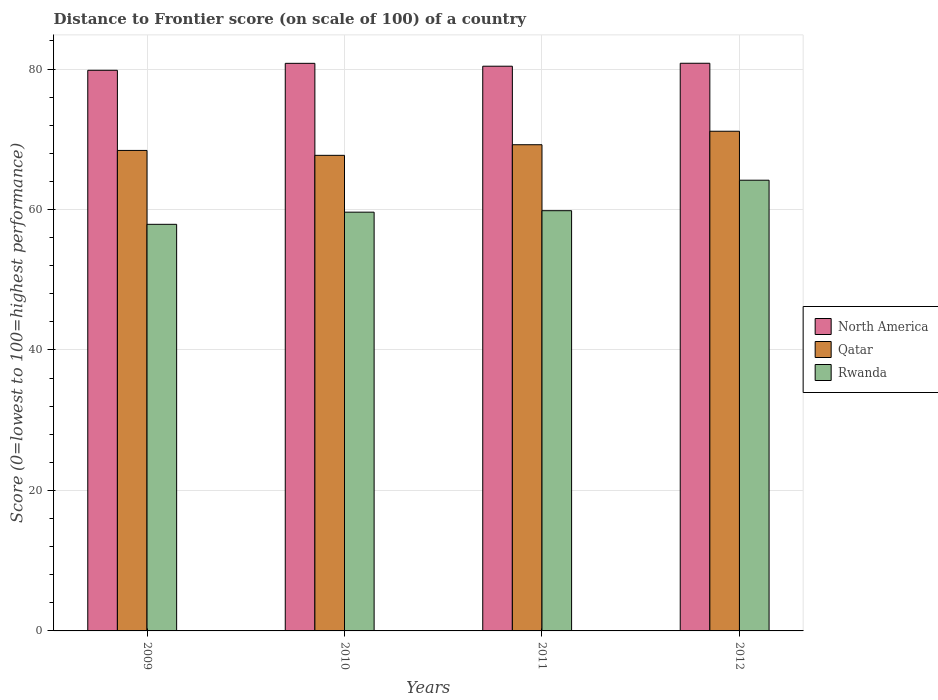How many different coloured bars are there?
Your answer should be very brief. 3. How many bars are there on the 4th tick from the left?
Provide a succinct answer. 3. How many bars are there on the 4th tick from the right?
Your answer should be compact. 3. What is the distance to frontier score of in Rwanda in 2012?
Make the answer very short. 64.17. Across all years, what is the maximum distance to frontier score of in Rwanda?
Offer a terse response. 64.17. Across all years, what is the minimum distance to frontier score of in Qatar?
Your response must be concise. 67.71. What is the total distance to frontier score of in North America in the graph?
Give a very brief answer. 321.85. What is the difference between the distance to frontier score of in Qatar in 2010 and that in 2011?
Your answer should be very brief. -1.51. What is the difference between the distance to frontier score of in Rwanda in 2011 and the distance to frontier score of in Qatar in 2009?
Your answer should be compact. -8.58. What is the average distance to frontier score of in Qatar per year?
Offer a terse response. 69.12. In the year 2009, what is the difference between the distance to frontier score of in Rwanda and distance to frontier score of in North America?
Ensure brevity in your answer.  -21.93. What is the ratio of the distance to frontier score of in North America in 2011 to that in 2012?
Provide a short and direct response. 0.99. Is the difference between the distance to frontier score of in Rwanda in 2010 and 2012 greater than the difference between the distance to frontier score of in North America in 2010 and 2012?
Your answer should be compact. No. What is the difference between the highest and the second highest distance to frontier score of in North America?
Make the answer very short. 0.01. What is the difference between the highest and the lowest distance to frontier score of in Qatar?
Your response must be concise. 3.43. In how many years, is the distance to frontier score of in Rwanda greater than the average distance to frontier score of in Rwanda taken over all years?
Your answer should be very brief. 1. What does the 3rd bar from the left in 2009 represents?
Give a very brief answer. Rwanda. What does the 3rd bar from the right in 2012 represents?
Your answer should be compact. North America. Is it the case that in every year, the sum of the distance to frontier score of in North America and distance to frontier score of in Qatar is greater than the distance to frontier score of in Rwanda?
Provide a short and direct response. Yes. How many bars are there?
Offer a very short reply. 12. How many years are there in the graph?
Your answer should be compact. 4. What is the difference between two consecutive major ticks on the Y-axis?
Give a very brief answer. 20. Does the graph contain any zero values?
Give a very brief answer. No. Does the graph contain grids?
Your answer should be very brief. Yes. How are the legend labels stacked?
Offer a terse response. Vertical. What is the title of the graph?
Your answer should be compact. Distance to Frontier score (on scale of 100) of a country. What is the label or title of the X-axis?
Give a very brief answer. Years. What is the label or title of the Y-axis?
Offer a terse response. Score (0=lowest to 100=highest performance). What is the Score (0=lowest to 100=highest performance) in North America in 2009?
Provide a succinct answer. 79.82. What is the Score (0=lowest to 100=highest performance) of Qatar in 2009?
Provide a succinct answer. 68.41. What is the Score (0=lowest to 100=highest performance) in Rwanda in 2009?
Offer a terse response. 57.89. What is the Score (0=lowest to 100=highest performance) of North America in 2010?
Provide a succinct answer. 80.81. What is the Score (0=lowest to 100=highest performance) in Qatar in 2010?
Make the answer very short. 67.71. What is the Score (0=lowest to 100=highest performance) in Rwanda in 2010?
Your answer should be compact. 59.62. What is the Score (0=lowest to 100=highest performance) of North America in 2011?
Provide a short and direct response. 80.4. What is the Score (0=lowest to 100=highest performance) of Qatar in 2011?
Ensure brevity in your answer.  69.22. What is the Score (0=lowest to 100=highest performance) of Rwanda in 2011?
Offer a terse response. 59.83. What is the Score (0=lowest to 100=highest performance) in North America in 2012?
Offer a very short reply. 80.82. What is the Score (0=lowest to 100=highest performance) in Qatar in 2012?
Your response must be concise. 71.14. What is the Score (0=lowest to 100=highest performance) in Rwanda in 2012?
Make the answer very short. 64.17. Across all years, what is the maximum Score (0=lowest to 100=highest performance) of North America?
Ensure brevity in your answer.  80.82. Across all years, what is the maximum Score (0=lowest to 100=highest performance) in Qatar?
Your answer should be very brief. 71.14. Across all years, what is the maximum Score (0=lowest to 100=highest performance) of Rwanda?
Make the answer very short. 64.17. Across all years, what is the minimum Score (0=lowest to 100=highest performance) in North America?
Make the answer very short. 79.82. Across all years, what is the minimum Score (0=lowest to 100=highest performance) in Qatar?
Your response must be concise. 67.71. Across all years, what is the minimum Score (0=lowest to 100=highest performance) of Rwanda?
Provide a short and direct response. 57.89. What is the total Score (0=lowest to 100=highest performance) in North America in the graph?
Your answer should be compact. 321.85. What is the total Score (0=lowest to 100=highest performance) of Qatar in the graph?
Your answer should be very brief. 276.48. What is the total Score (0=lowest to 100=highest performance) in Rwanda in the graph?
Provide a short and direct response. 241.51. What is the difference between the Score (0=lowest to 100=highest performance) of North America in 2009 and that in 2010?
Provide a succinct answer. -0.99. What is the difference between the Score (0=lowest to 100=highest performance) in Rwanda in 2009 and that in 2010?
Keep it short and to the point. -1.73. What is the difference between the Score (0=lowest to 100=highest performance) in North America in 2009 and that in 2011?
Keep it short and to the point. -0.58. What is the difference between the Score (0=lowest to 100=highest performance) in Qatar in 2009 and that in 2011?
Offer a very short reply. -0.81. What is the difference between the Score (0=lowest to 100=highest performance) in Rwanda in 2009 and that in 2011?
Your response must be concise. -1.94. What is the difference between the Score (0=lowest to 100=highest performance) in Qatar in 2009 and that in 2012?
Ensure brevity in your answer.  -2.73. What is the difference between the Score (0=lowest to 100=highest performance) of Rwanda in 2009 and that in 2012?
Your answer should be very brief. -6.28. What is the difference between the Score (0=lowest to 100=highest performance) of North America in 2010 and that in 2011?
Your answer should be very brief. 0.41. What is the difference between the Score (0=lowest to 100=highest performance) of Qatar in 2010 and that in 2011?
Keep it short and to the point. -1.51. What is the difference between the Score (0=lowest to 100=highest performance) in Rwanda in 2010 and that in 2011?
Ensure brevity in your answer.  -0.21. What is the difference between the Score (0=lowest to 100=highest performance) of North America in 2010 and that in 2012?
Your answer should be very brief. -0.01. What is the difference between the Score (0=lowest to 100=highest performance) of Qatar in 2010 and that in 2012?
Provide a succinct answer. -3.43. What is the difference between the Score (0=lowest to 100=highest performance) in Rwanda in 2010 and that in 2012?
Give a very brief answer. -4.55. What is the difference between the Score (0=lowest to 100=highest performance) of North America in 2011 and that in 2012?
Make the answer very short. -0.42. What is the difference between the Score (0=lowest to 100=highest performance) in Qatar in 2011 and that in 2012?
Give a very brief answer. -1.92. What is the difference between the Score (0=lowest to 100=highest performance) in Rwanda in 2011 and that in 2012?
Your response must be concise. -4.34. What is the difference between the Score (0=lowest to 100=highest performance) in North America in 2009 and the Score (0=lowest to 100=highest performance) in Qatar in 2010?
Offer a very short reply. 12.11. What is the difference between the Score (0=lowest to 100=highest performance) in North America in 2009 and the Score (0=lowest to 100=highest performance) in Rwanda in 2010?
Provide a short and direct response. 20.2. What is the difference between the Score (0=lowest to 100=highest performance) of Qatar in 2009 and the Score (0=lowest to 100=highest performance) of Rwanda in 2010?
Your response must be concise. 8.79. What is the difference between the Score (0=lowest to 100=highest performance) of North America in 2009 and the Score (0=lowest to 100=highest performance) of Rwanda in 2011?
Provide a short and direct response. 19.99. What is the difference between the Score (0=lowest to 100=highest performance) of Qatar in 2009 and the Score (0=lowest to 100=highest performance) of Rwanda in 2011?
Keep it short and to the point. 8.58. What is the difference between the Score (0=lowest to 100=highest performance) of North America in 2009 and the Score (0=lowest to 100=highest performance) of Qatar in 2012?
Provide a succinct answer. 8.68. What is the difference between the Score (0=lowest to 100=highest performance) of North America in 2009 and the Score (0=lowest to 100=highest performance) of Rwanda in 2012?
Your response must be concise. 15.65. What is the difference between the Score (0=lowest to 100=highest performance) in Qatar in 2009 and the Score (0=lowest to 100=highest performance) in Rwanda in 2012?
Offer a terse response. 4.24. What is the difference between the Score (0=lowest to 100=highest performance) of North America in 2010 and the Score (0=lowest to 100=highest performance) of Qatar in 2011?
Provide a short and direct response. 11.59. What is the difference between the Score (0=lowest to 100=highest performance) of North America in 2010 and the Score (0=lowest to 100=highest performance) of Rwanda in 2011?
Offer a terse response. 20.98. What is the difference between the Score (0=lowest to 100=highest performance) of Qatar in 2010 and the Score (0=lowest to 100=highest performance) of Rwanda in 2011?
Your answer should be very brief. 7.88. What is the difference between the Score (0=lowest to 100=highest performance) in North America in 2010 and the Score (0=lowest to 100=highest performance) in Qatar in 2012?
Provide a succinct answer. 9.67. What is the difference between the Score (0=lowest to 100=highest performance) of North America in 2010 and the Score (0=lowest to 100=highest performance) of Rwanda in 2012?
Provide a succinct answer. 16.64. What is the difference between the Score (0=lowest to 100=highest performance) in Qatar in 2010 and the Score (0=lowest to 100=highest performance) in Rwanda in 2012?
Make the answer very short. 3.54. What is the difference between the Score (0=lowest to 100=highest performance) of North America in 2011 and the Score (0=lowest to 100=highest performance) of Qatar in 2012?
Your answer should be very brief. 9.26. What is the difference between the Score (0=lowest to 100=highest performance) of North America in 2011 and the Score (0=lowest to 100=highest performance) of Rwanda in 2012?
Your answer should be compact. 16.23. What is the difference between the Score (0=lowest to 100=highest performance) of Qatar in 2011 and the Score (0=lowest to 100=highest performance) of Rwanda in 2012?
Offer a terse response. 5.05. What is the average Score (0=lowest to 100=highest performance) of North America per year?
Your answer should be compact. 80.46. What is the average Score (0=lowest to 100=highest performance) of Qatar per year?
Your response must be concise. 69.12. What is the average Score (0=lowest to 100=highest performance) in Rwanda per year?
Offer a very short reply. 60.38. In the year 2009, what is the difference between the Score (0=lowest to 100=highest performance) in North America and Score (0=lowest to 100=highest performance) in Qatar?
Your answer should be very brief. 11.41. In the year 2009, what is the difference between the Score (0=lowest to 100=highest performance) in North America and Score (0=lowest to 100=highest performance) in Rwanda?
Ensure brevity in your answer.  21.93. In the year 2009, what is the difference between the Score (0=lowest to 100=highest performance) in Qatar and Score (0=lowest to 100=highest performance) in Rwanda?
Your answer should be compact. 10.52. In the year 2010, what is the difference between the Score (0=lowest to 100=highest performance) in North America and Score (0=lowest to 100=highest performance) in Rwanda?
Provide a short and direct response. 21.19. In the year 2010, what is the difference between the Score (0=lowest to 100=highest performance) of Qatar and Score (0=lowest to 100=highest performance) of Rwanda?
Offer a terse response. 8.09. In the year 2011, what is the difference between the Score (0=lowest to 100=highest performance) in North America and Score (0=lowest to 100=highest performance) in Qatar?
Provide a succinct answer. 11.18. In the year 2011, what is the difference between the Score (0=lowest to 100=highest performance) of North America and Score (0=lowest to 100=highest performance) of Rwanda?
Provide a short and direct response. 20.57. In the year 2011, what is the difference between the Score (0=lowest to 100=highest performance) of Qatar and Score (0=lowest to 100=highest performance) of Rwanda?
Give a very brief answer. 9.39. In the year 2012, what is the difference between the Score (0=lowest to 100=highest performance) in North America and Score (0=lowest to 100=highest performance) in Qatar?
Provide a succinct answer. 9.68. In the year 2012, what is the difference between the Score (0=lowest to 100=highest performance) of North America and Score (0=lowest to 100=highest performance) of Rwanda?
Provide a short and direct response. 16.65. In the year 2012, what is the difference between the Score (0=lowest to 100=highest performance) in Qatar and Score (0=lowest to 100=highest performance) in Rwanda?
Keep it short and to the point. 6.97. What is the ratio of the Score (0=lowest to 100=highest performance) of Qatar in 2009 to that in 2010?
Ensure brevity in your answer.  1.01. What is the ratio of the Score (0=lowest to 100=highest performance) of Qatar in 2009 to that in 2011?
Make the answer very short. 0.99. What is the ratio of the Score (0=lowest to 100=highest performance) of Rwanda in 2009 to that in 2011?
Offer a terse response. 0.97. What is the ratio of the Score (0=lowest to 100=highest performance) of North America in 2009 to that in 2012?
Make the answer very short. 0.99. What is the ratio of the Score (0=lowest to 100=highest performance) of Qatar in 2009 to that in 2012?
Make the answer very short. 0.96. What is the ratio of the Score (0=lowest to 100=highest performance) in Rwanda in 2009 to that in 2012?
Provide a succinct answer. 0.9. What is the ratio of the Score (0=lowest to 100=highest performance) in North America in 2010 to that in 2011?
Offer a terse response. 1.01. What is the ratio of the Score (0=lowest to 100=highest performance) of Qatar in 2010 to that in 2011?
Make the answer very short. 0.98. What is the ratio of the Score (0=lowest to 100=highest performance) of Rwanda in 2010 to that in 2011?
Provide a short and direct response. 1. What is the ratio of the Score (0=lowest to 100=highest performance) of Qatar in 2010 to that in 2012?
Offer a very short reply. 0.95. What is the ratio of the Score (0=lowest to 100=highest performance) of Rwanda in 2010 to that in 2012?
Give a very brief answer. 0.93. What is the ratio of the Score (0=lowest to 100=highest performance) of Rwanda in 2011 to that in 2012?
Provide a succinct answer. 0.93. What is the difference between the highest and the second highest Score (0=lowest to 100=highest performance) of North America?
Offer a very short reply. 0.01. What is the difference between the highest and the second highest Score (0=lowest to 100=highest performance) of Qatar?
Your response must be concise. 1.92. What is the difference between the highest and the second highest Score (0=lowest to 100=highest performance) in Rwanda?
Ensure brevity in your answer.  4.34. What is the difference between the highest and the lowest Score (0=lowest to 100=highest performance) of Qatar?
Give a very brief answer. 3.43. What is the difference between the highest and the lowest Score (0=lowest to 100=highest performance) in Rwanda?
Provide a succinct answer. 6.28. 